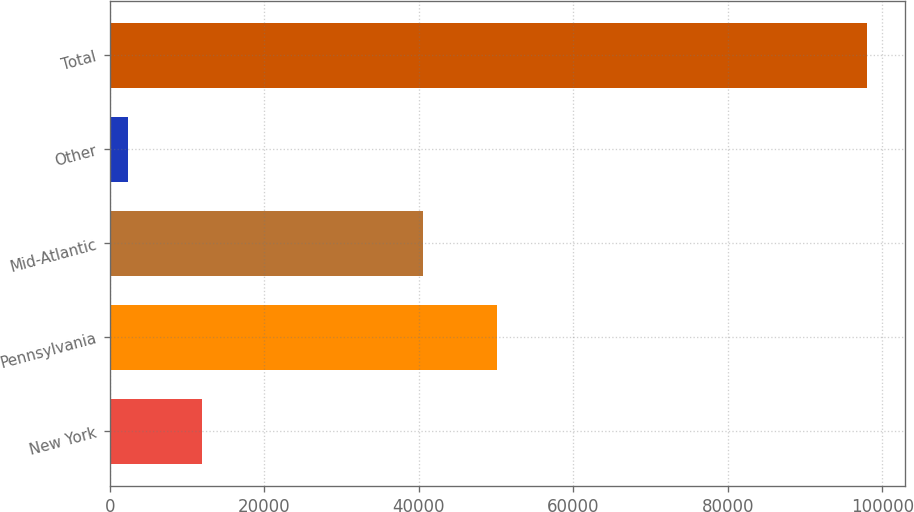<chart> <loc_0><loc_0><loc_500><loc_500><bar_chart><fcel>New York<fcel>Pennsylvania<fcel>Mid-Atlantic<fcel>Other<fcel>Total<nl><fcel>11894.8<fcel>50093.8<fcel>40518<fcel>2319<fcel>98077<nl></chart> 